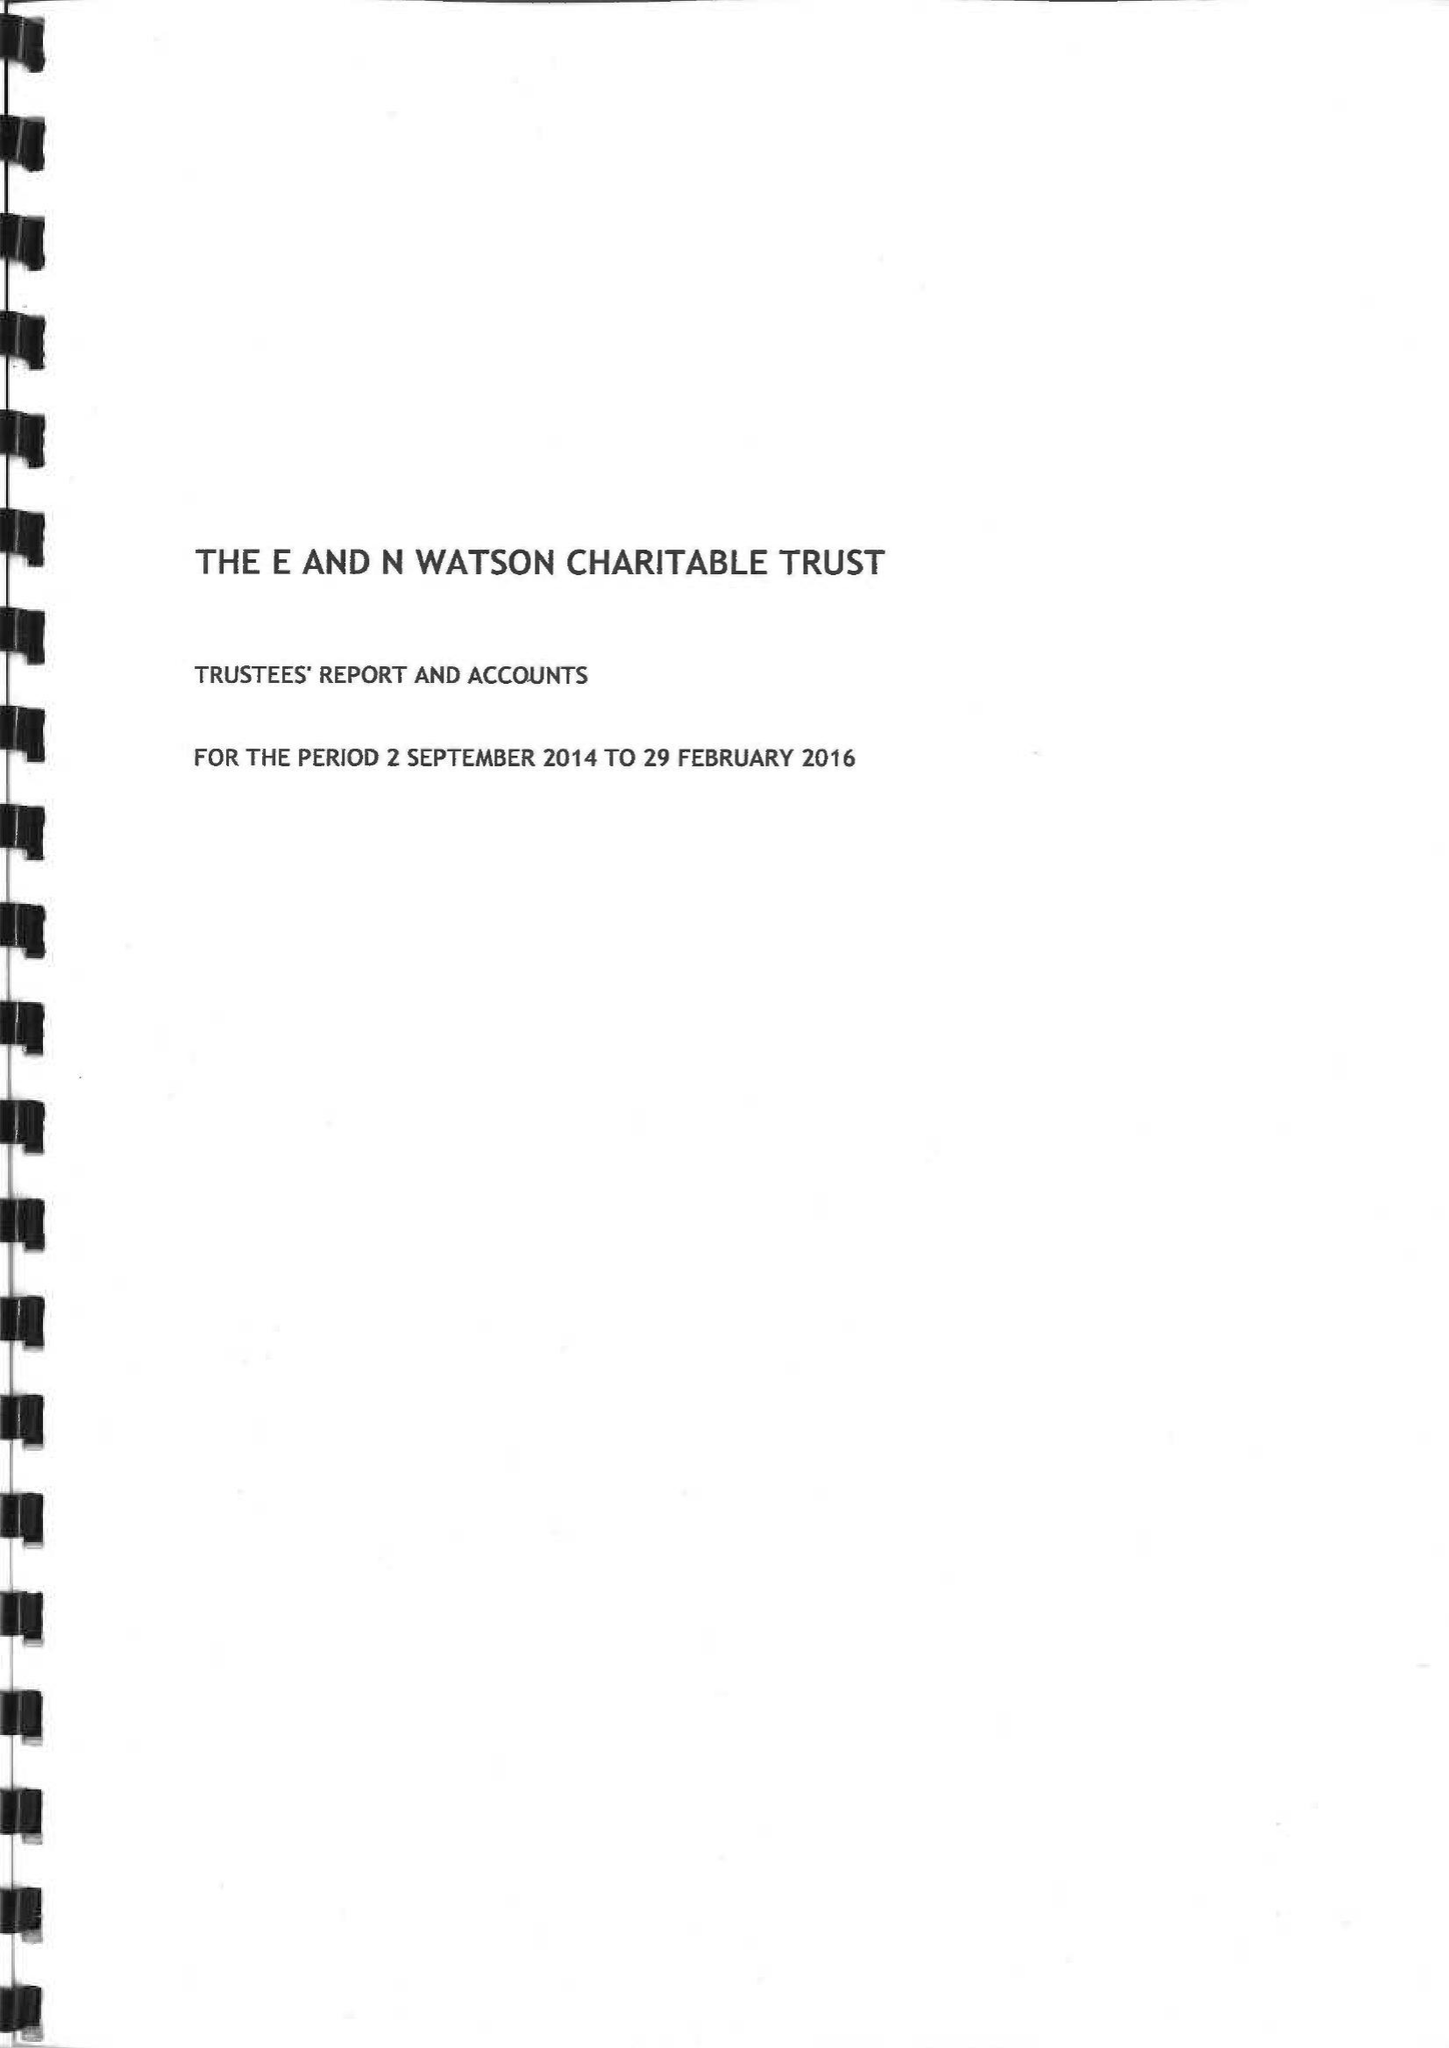What is the value for the address__postcode?
Answer the question using a single word or phrase. SP1 2SB 